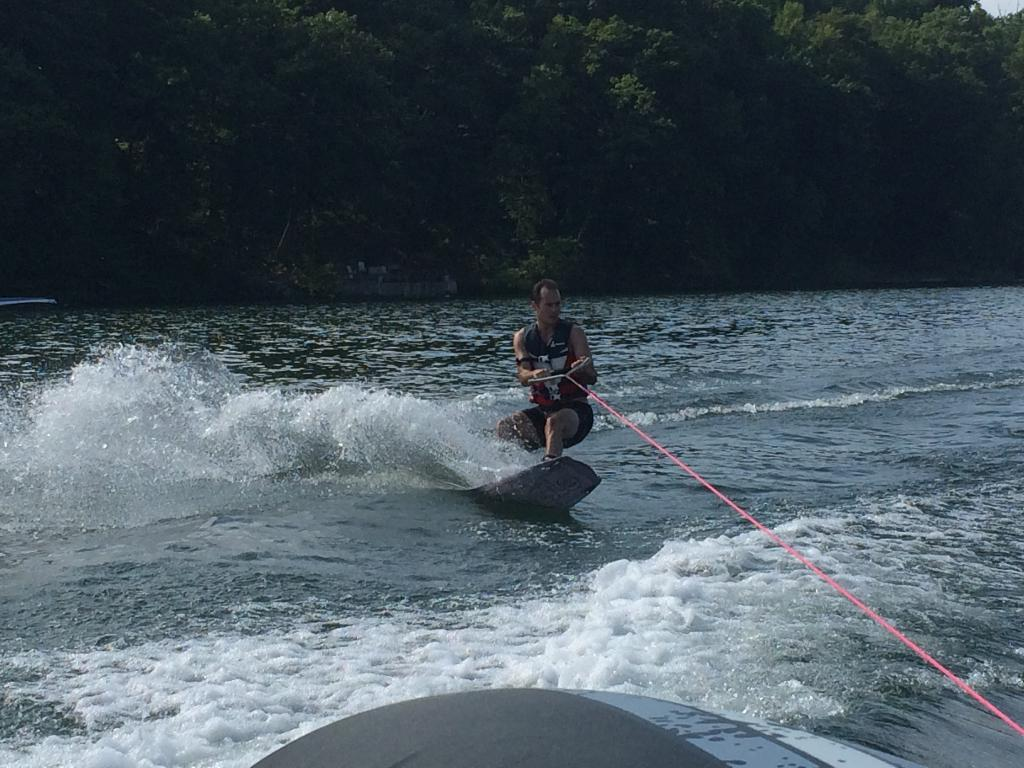What activity is the person in the image engaged in? The person is skateboarding in the image. On what surface is the person skateboarding? The person is skateboarding on a water body. What type of natural environment is visible in the image? There is a group of trees visible in the image. What is visible above the person and the water body? The sky is visible in the image. What type of plastic is being used by the fairies to build their homes in the image? There are no fairies or plastic present in the image. 